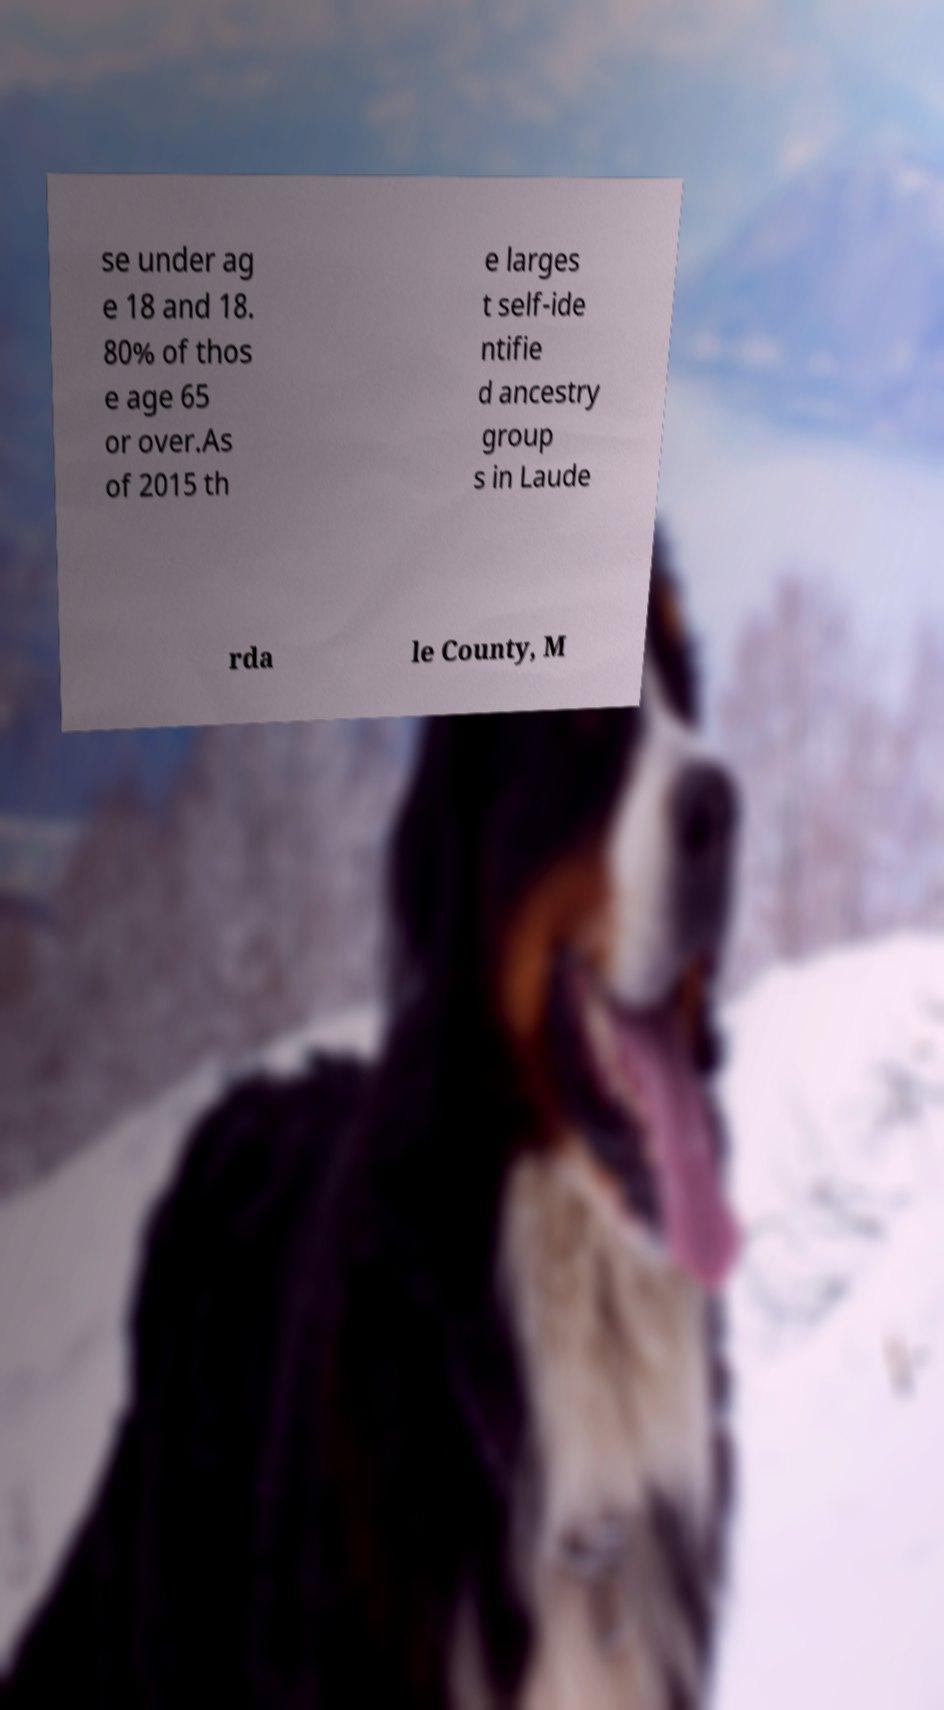I need the written content from this picture converted into text. Can you do that? se under ag e 18 and 18. 80% of thos e age 65 or over.As of 2015 th e larges t self-ide ntifie d ancestry group s in Laude rda le County, M 